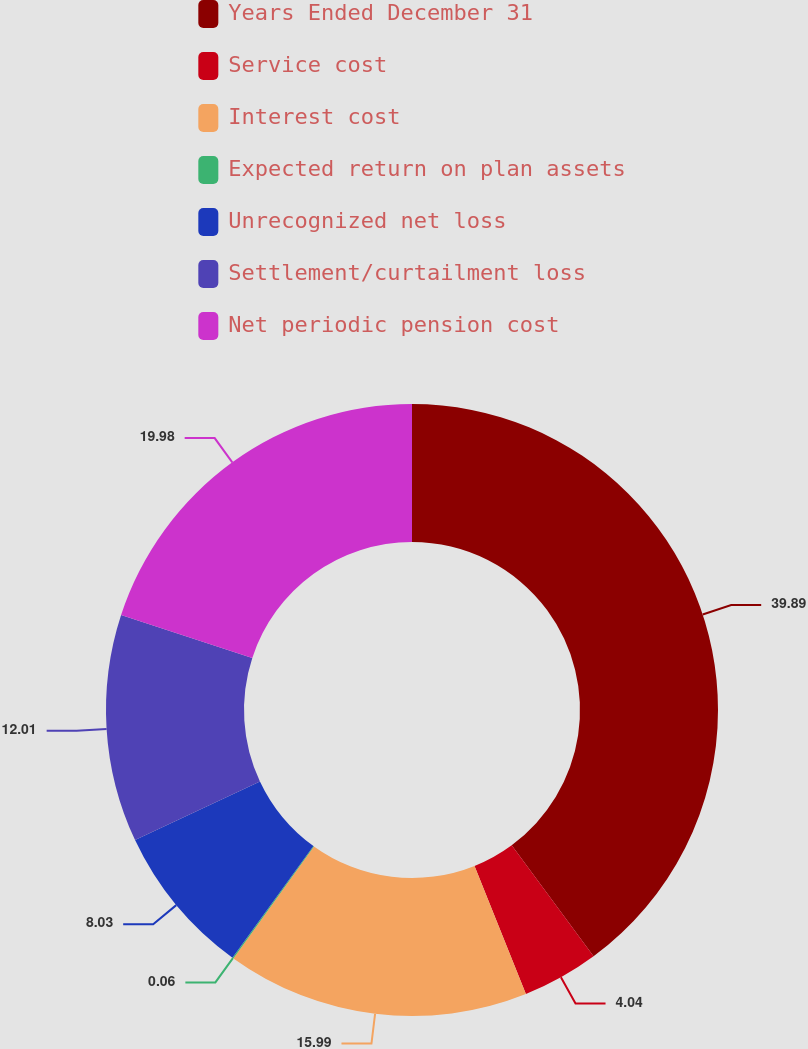Convert chart. <chart><loc_0><loc_0><loc_500><loc_500><pie_chart><fcel>Years Ended December 31<fcel>Service cost<fcel>Interest cost<fcel>Expected return on plan assets<fcel>Unrecognized net loss<fcel>Settlement/curtailment loss<fcel>Net periodic pension cost<nl><fcel>39.89%<fcel>4.04%<fcel>15.99%<fcel>0.06%<fcel>8.03%<fcel>12.01%<fcel>19.98%<nl></chart> 